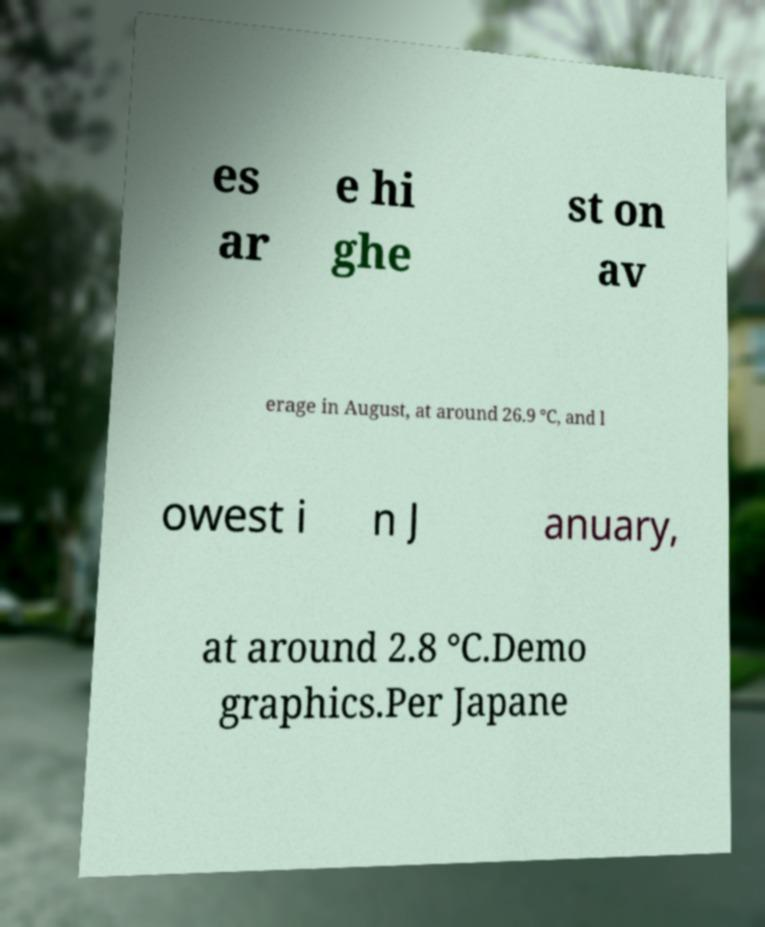Can you accurately transcribe the text from the provided image for me? es ar e hi ghe st on av erage in August, at around 26.9 °C, and l owest i n J anuary, at around 2.8 °C.Demo graphics.Per Japane 